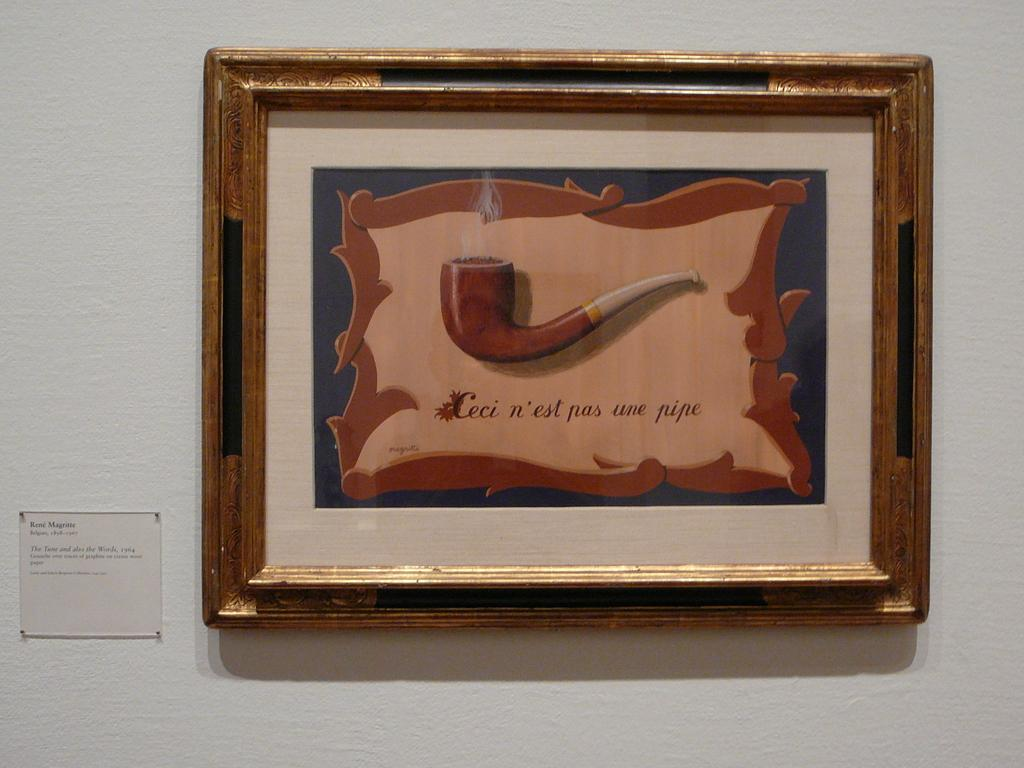<image>
Create a compact narrative representing the image presented. An antique looking frame with a picture of a pipe by artist Renee Magritte hangs on a white wall. 